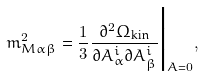Convert formula to latex. <formula><loc_0><loc_0><loc_500><loc_500>m _ { M \alpha \beta } ^ { 2 } = \frac { 1 } { 3 } \frac { \partial ^ { 2 } \Omega _ { \text {kin} } } { \partial A _ { \alpha } ^ { i } \partial A _ { \beta } ^ { i } } \Big | _ { A = 0 } ,</formula> 